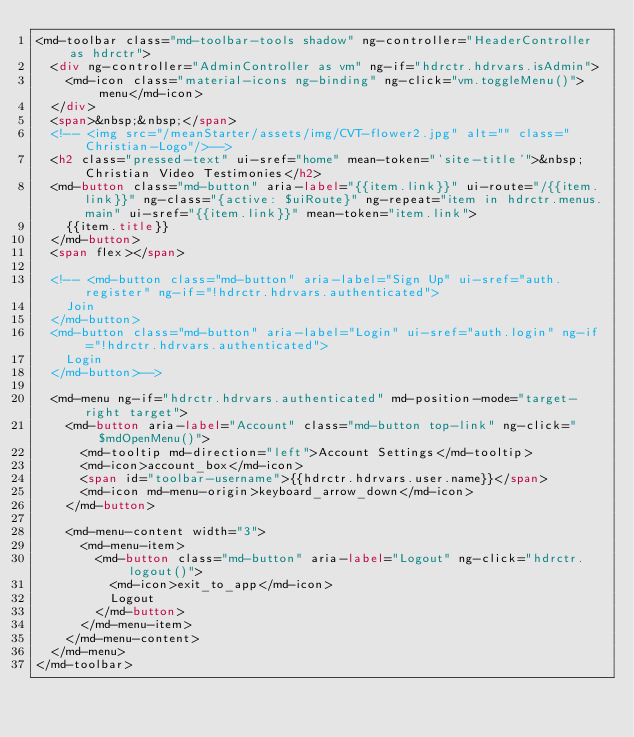<code> <loc_0><loc_0><loc_500><loc_500><_HTML_><md-toolbar class="md-toolbar-tools shadow" ng-controller="HeaderController as hdrctr">
  <div ng-controller="AdminController as vm" ng-if="hdrctr.hdrvars.isAdmin">
    <md-icon class="material-icons ng-binding" ng-click="vm.toggleMenu()">menu</md-icon>
  </div>
  <span>&nbsp;&nbsp;</span>
  <!-- <img src="/meanStarter/assets/img/CVT-flower2.jpg" alt="" class="Christian-Logo"/>-->
  <h2 class="pressed-text" ui-sref="home" mean-token="'site-title'">&nbsp;Christian Video Testimonies</h2>
  <md-button class="md-button" aria-label="{{item.link}}" ui-route="/{{item.link}}" ng-class="{active: $uiRoute}" ng-repeat="item in hdrctr.menus.main" ui-sref="{{item.link}}" mean-token="item.link">
    {{item.title}}
  </md-button>
  <span flex></span>

  <!-- <md-button class="md-button" aria-label="Sign Up" ui-sref="auth.register" ng-if="!hdrctr.hdrvars.authenticated">
    Join
  </md-button>
  <md-button class="md-button" aria-label="Login" ui-sref="auth.login" ng-if="!hdrctr.hdrvars.authenticated">
    Login
  </md-button>-->

  <md-menu ng-if="hdrctr.hdrvars.authenticated" md-position-mode="target-right target">
    <md-button aria-label="Account" class="md-button top-link" ng-click="$mdOpenMenu()">
      <md-tooltip md-direction="left">Account Settings</md-tooltip>
      <md-icon>account_box</md-icon>
      <span id="toolbar-username">{{hdrctr.hdrvars.user.name}}</span>
      <md-icon md-menu-origin>keyboard_arrow_down</md-icon>
    </md-button>

    <md-menu-content width="3">
      <md-menu-item>
        <md-button class="md-button" aria-label="Logout" ng-click="hdrctr.logout()">
          <md-icon>exit_to_app</md-icon>
          Logout
        </md-button>
      </md-menu-item>
    </md-menu-content>
  </md-menu>
</md-toolbar>
</code> 